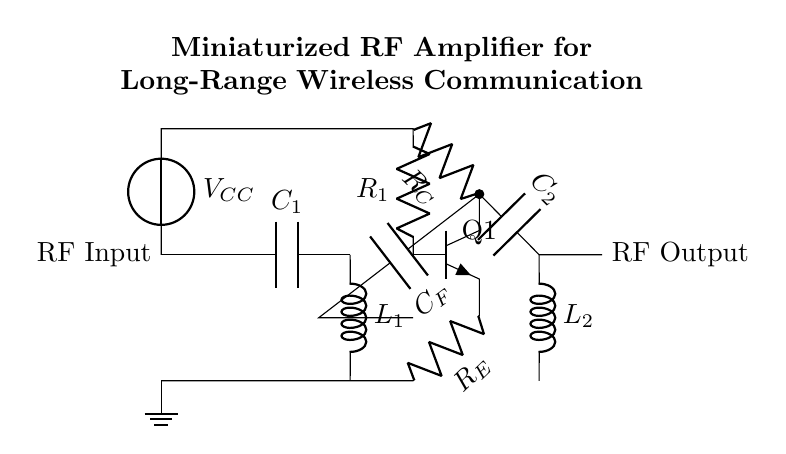What is the value of the output coupling capacitor? The value of the output coupling capacitor, labeled as C2 in the circuit diagram, is not specified numerically but is represented as a capacitor.
Answer: C2 What is the function of the resistor R1? R1 is a biasing resistor connected to the base of the transistor Q1, providing the necessary base current for proper amplification in the transistor.
Answer: Biasing What type of transistor is used in this circuit? The circuit shows an npn transistor configuration, as indicated by the symbol for Q1 and its specific labeling.
Answer: NPN What is the purpose of the inductor L1? L1 is used for impedance matching at the input stage of the amplifier, optimizing the RF signal for maximum power transfer into the amplifier.
Answer: Impedance matching How many capacitors are present in the circuit? By counting the components labeled as capacitors, there are three capacitors indicated in the circuit layout: C1, C2, and CF.
Answer: Three What is the reference point for the emitter resistor R_E? The emitter resistor R_E is connected to the ground, which establishes a reference point for the emitter of the transistor to aid in stabilizing the amplifier's operation.
Answer: Ground What is the relationship between R_C and the collector of Q1? R_C is connected between the collector of Q1 and the power supply, influencing the output voltage and the gain of the amplifier by setting the load on the collector of the transistor.
Answer: Connected 